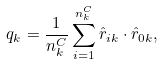Convert formula to latex. <formula><loc_0><loc_0><loc_500><loc_500>q _ { k } = \frac { 1 } { n ^ { C } _ { k } } \sum ^ { n ^ { C } _ { k } } _ { i = 1 } \hat { r } _ { i k } \cdot \hat { r } _ { 0 k } ,</formula> 